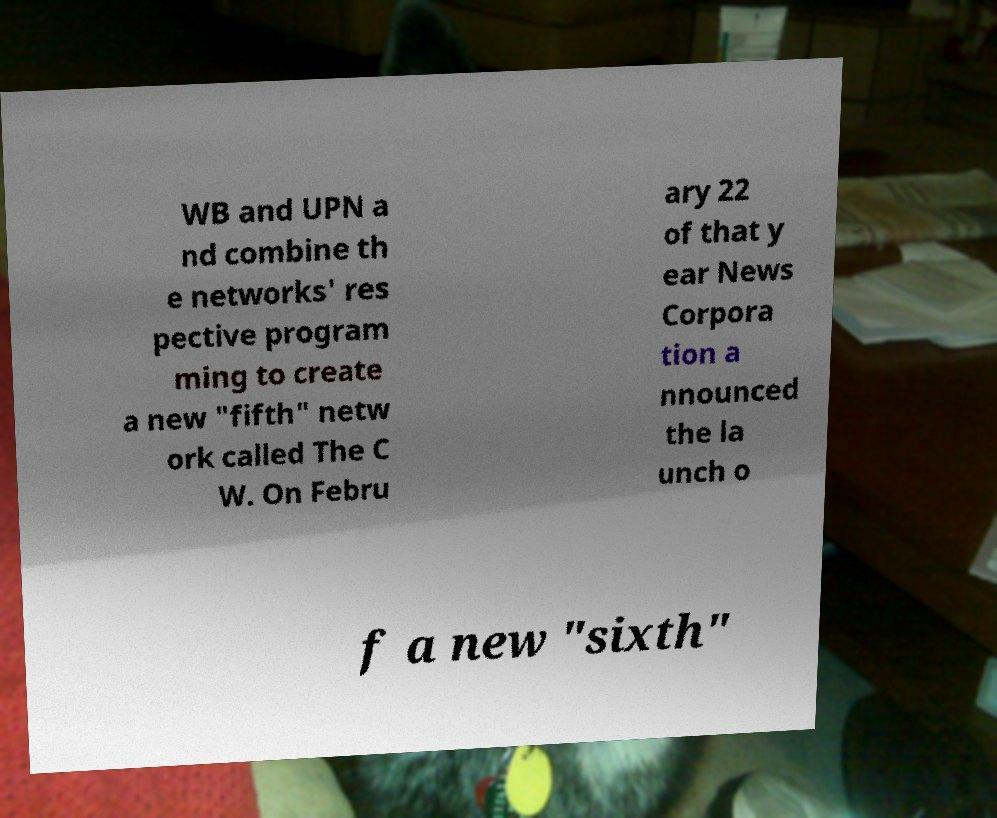Can you accurately transcribe the text from the provided image for me? WB and UPN a nd combine th e networks' res pective program ming to create a new "fifth" netw ork called The C W. On Febru ary 22 of that y ear News Corpora tion a nnounced the la unch o f a new "sixth" 